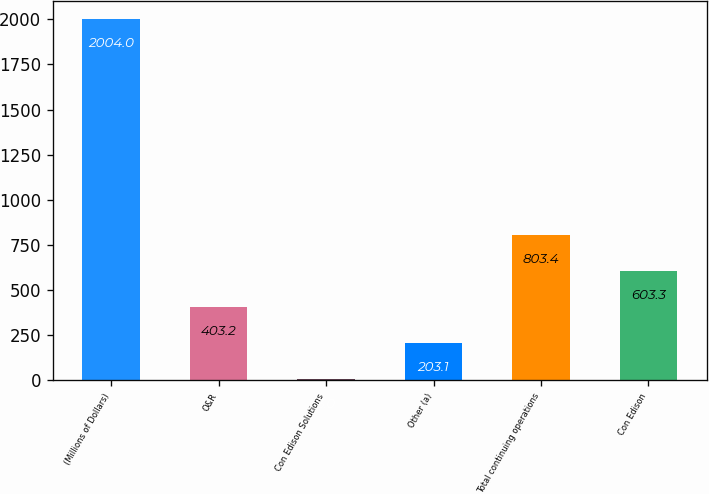<chart> <loc_0><loc_0><loc_500><loc_500><bar_chart><fcel>(Millions of Dollars)<fcel>O&R<fcel>Con Edison Solutions<fcel>Other (a)<fcel>Total continuing operations<fcel>Con Edison<nl><fcel>2004<fcel>403.2<fcel>3<fcel>203.1<fcel>803.4<fcel>603.3<nl></chart> 